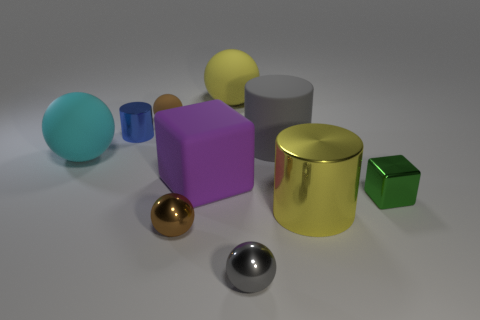What shape is the small metal object that is right of the metal sphere right of the large yellow thing behind the small blue shiny cylinder?
Your answer should be compact. Cube. Is there a yellow cylinder?
Your response must be concise. Yes. There is a gray metallic ball; is its size the same as the shiny cylinder that is behind the tiny green cube?
Keep it short and to the point. Yes. There is a metallic sphere right of the large yellow rubber ball; are there any blue cylinders right of it?
Provide a succinct answer. No. There is a sphere that is to the right of the big purple matte cube and behind the blue object; what material is it?
Make the answer very short. Rubber. What is the color of the big matte thing that is to the left of the tiny brown ball behind the large cylinder that is in front of the gray cylinder?
Offer a very short reply. Cyan. There is a metallic cylinder that is the same size as the purple rubber thing; what color is it?
Give a very brief answer. Yellow. There is a small matte thing; is its color the same as the big object to the left of the purple matte cube?
Offer a very short reply. No. What material is the brown object in front of the big cylinder behind the big metal cylinder?
Your response must be concise. Metal. What number of balls are both behind the tiny brown metal sphere and to the right of the yellow ball?
Your answer should be compact. 0. 